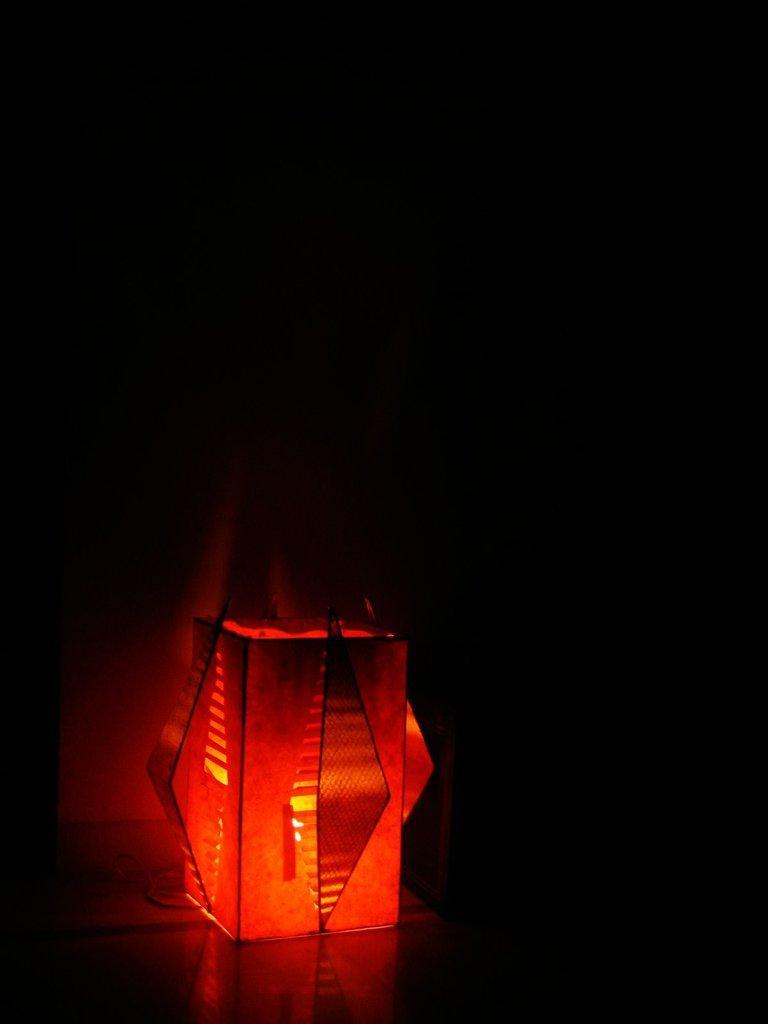Please provide a concise description of this image. This image consists of a light. It is in red color. It is at the bottom. 